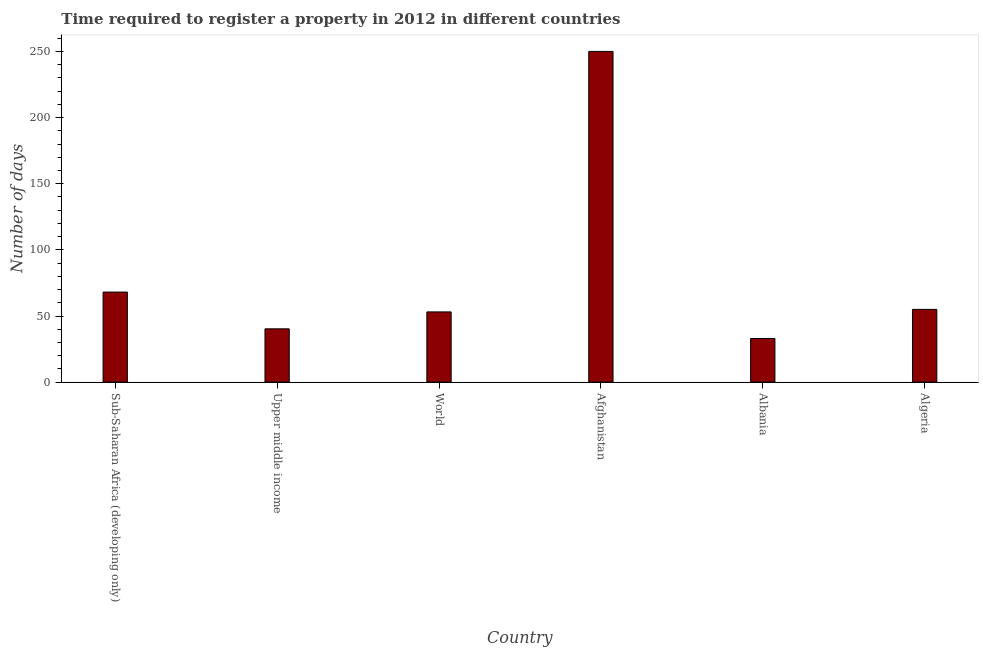Does the graph contain grids?
Ensure brevity in your answer.  No. What is the title of the graph?
Your response must be concise. Time required to register a property in 2012 in different countries. What is the label or title of the Y-axis?
Keep it short and to the point. Number of days. What is the number of days required to register property in Afghanistan?
Make the answer very short. 250. Across all countries, what is the maximum number of days required to register property?
Offer a very short reply. 250. In which country was the number of days required to register property maximum?
Your answer should be very brief. Afghanistan. In which country was the number of days required to register property minimum?
Give a very brief answer. Albania. What is the sum of the number of days required to register property?
Offer a terse response. 499.48. What is the difference between the number of days required to register property in Algeria and World?
Make the answer very short. 1.91. What is the average number of days required to register property per country?
Provide a succinct answer. 83.25. What is the median number of days required to register property?
Offer a terse response. 54.05. What is the ratio of the number of days required to register property in Upper middle income to that in World?
Give a very brief answer. 0.76. Is the number of days required to register property in Afghanistan less than that in Sub-Saharan Africa (developing only)?
Your answer should be compact. No. What is the difference between the highest and the second highest number of days required to register property?
Your answer should be very brief. 181.91. Is the sum of the number of days required to register property in Afghanistan and Algeria greater than the maximum number of days required to register property across all countries?
Keep it short and to the point. Yes. What is the difference between the highest and the lowest number of days required to register property?
Provide a succinct answer. 217. How many bars are there?
Your answer should be compact. 6. What is the difference between two consecutive major ticks on the Y-axis?
Keep it short and to the point. 50. Are the values on the major ticks of Y-axis written in scientific E-notation?
Ensure brevity in your answer.  No. What is the Number of days of Sub-Saharan Africa (developing only)?
Your answer should be very brief. 68.09. What is the Number of days of Upper middle income?
Provide a short and direct response. 40.3. What is the Number of days in World?
Provide a succinct answer. 53.09. What is the Number of days in Afghanistan?
Your response must be concise. 250. What is the difference between the Number of days in Sub-Saharan Africa (developing only) and Upper middle income?
Provide a short and direct response. 27.8. What is the difference between the Number of days in Sub-Saharan Africa (developing only) and World?
Provide a succinct answer. 15. What is the difference between the Number of days in Sub-Saharan Africa (developing only) and Afghanistan?
Your answer should be very brief. -181.91. What is the difference between the Number of days in Sub-Saharan Africa (developing only) and Albania?
Your answer should be very brief. 35.09. What is the difference between the Number of days in Sub-Saharan Africa (developing only) and Algeria?
Keep it short and to the point. 13.09. What is the difference between the Number of days in Upper middle income and World?
Your answer should be compact. -12.8. What is the difference between the Number of days in Upper middle income and Afghanistan?
Give a very brief answer. -209.7. What is the difference between the Number of days in Upper middle income and Albania?
Give a very brief answer. 7.3. What is the difference between the Number of days in Upper middle income and Algeria?
Offer a terse response. -14.7. What is the difference between the Number of days in World and Afghanistan?
Your answer should be very brief. -196.91. What is the difference between the Number of days in World and Albania?
Your response must be concise. 20.09. What is the difference between the Number of days in World and Algeria?
Provide a short and direct response. -1.91. What is the difference between the Number of days in Afghanistan and Albania?
Provide a short and direct response. 217. What is the difference between the Number of days in Afghanistan and Algeria?
Offer a terse response. 195. What is the ratio of the Number of days in Sub-Saharan Africa (developing only) to that in Upper middle income?
Provide a short and direct response. 1.69. What is the ratio of the Number of days in Sub-Saharan Africa (developing only) to that in World?
Offer a very short reply. 1.28. What is the ratio of the Number of days in Sub-Saharan Africa (developing only) to that in Afghanistan?
Your answer should be compact. 0.27. What is the ratio of the Number of days in Sub-Saharan Africa (developing only) to that in Albania?
Make the answer very short. 2.06. What is the ratio of the Number of days in Sub-Saharan Africa (developing only) to that in Algeria?
Offer a terse response. 1.24. What is the ratio of the Number of days in Upper middle income to that in World?
Provide a short and direct response. 0.76. What is the ratio of the Number of days in Upper middle income to that in Afghanistan?
Your answer should be compact. 0.16. What is the ratio of the Number of days in Upper middle income to that in Albania?
Your response must be concise. 1.22. What is the ratio of the Number of days in Upper middle income to that in Algeria?
Make the answer very short. 0.73. What is the ratio of the Number of days in World to that in Afghanistan?
Offer a very short reply. 0.21. What is the ratio of the Number of days in World to that in Albania?
Ensure brevity in your answer.  1.61. What is the ratio of the Number of days in World to that in Algeria?
Your response must be concise. 0.96. What is the ratio of the Number of days in Afghanistan to that in Albania?
Provide a succinct answer. 7.58. What is the ratio of the Number of days in Afghanistan to that in Algeria?
Offer a terse response. 4.54. What is the ratio of the Number of days in Albania to that in Algeria?
Make the answer very short. 0.6. 